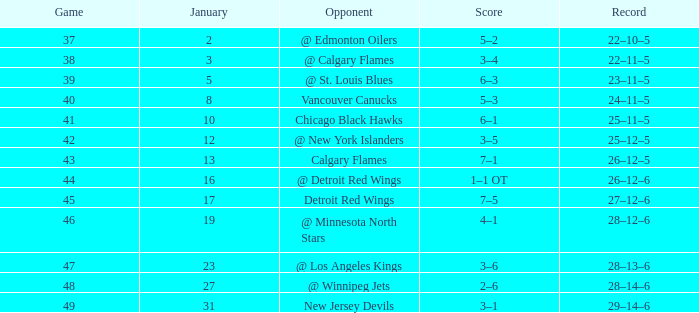In how many games does the score stand at 2-6, with the total points exceeding 62? 0.0. 